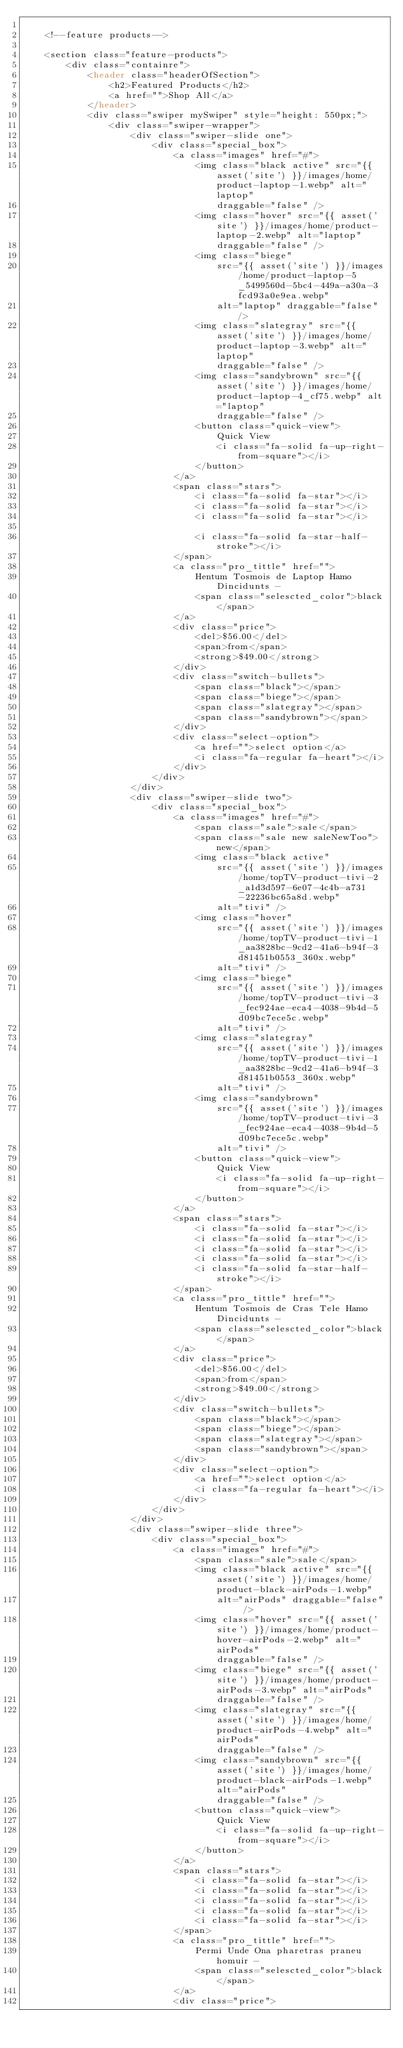Convert code to text. <code><loc_0><loc_0><loc_500><loc_500><_PHP_>
    <!--feature products-->

    <section class="feature-products">
        <div class="containre">
            <header class="headerOfSection">
                <h2>Featured Products</h2>
                <a href="">Shop All</a>
            </header>
            <div class="swiper mySwiper" style="height: 550px;">
                <div class="swiper-wrapper">
                    <div class="swiper-slide one">
                        <div class="special_box">
                            <a class="images" href="#">
                                <img class="black active" src="{{ asset('site') }}/images/home/product-laptop-1.webp" alt="laptop"
                                    draggable="false" />
                                <img class="hover" src="{{ asset('site') }}/images/home/product-laptop-2.webp" alt="laptop"
                                    draggable="false" />
                                <img class="biege"
                                    src="{{ asset('site') }}/images/home/product-laptop-5_5499560d-5bc4-449a-a30a-3fcd93a0e9ea.webp"
                                    alt="laptop" draggable="false" />
                                <img class="slategray" src="{{ asset('site') }}/images/home/product-laptop-3.webp" alt="laptop"
                                    draggable="false" />
                                <img class="sandybrown" src="{{ asset('site') }}/images/home/product-laptop-4_cf75.webp" alt="laptop"
                                    draggable="false" />
                                <button class="quick-view">
                                    Quick View
                                    <i class="fa-solid fa-up-right-from-square"></i>
                                </button>
                            </a>
                            <span class="stars">
                                <i class="fa-solid fa-star"></i>
                                <i class="fa-solid fa-star"></i>
                                <i class="fa-solid fa-star"></i>

                                <i class="fa-solid fa-star-half-stroke"></i>
                            </span>
                            <a class="pro_tittle" href="">
                                Hentum Tosmois de Laptop Hamo Dincidunts -
                                <span class="selescted_color">black</span>
                            </a>
                            <div class="price">
                                <del>$56.00</del>
                                <span>from</span>
                                <strong>$49.00</strong>
                            </div>
                            <div class="switch-bullets">
                                <span class="black"></span>
                                <span class="biege"></span>
                                <span class="slategray"></span>
                                <span class="sandybrown"></span>
                            </div>
                            <div class="select-option">
                                <a href="">select option</a>
                                <i class="fa-regular fa-heart"></i>
                            </div>
                        </div>
                    </div>
                    <div class="swiper-slide two">
                        <div class="special_box">
                            <a class="images" href="#">
                                <span class="sale">sale</span>
                                <span class="sale new saleNewToo">new</span>
                                <img class="black active"
                                    src="{{ asset('site') }}/images/home/topTV-product-tivi-2_a1d3d597-6e07-4c4b-a731-22236bc65a8d.webp"
                                    alt="tivi" />
                                <img class="hover"
                                    src="{{ asset('site') }}/images/home/topTV-product-tivi-1_aa3828bc-9cd2-41a6-b94f-3d81451b0553_360x.webp"
                                    alt="tivi" />
                                <img class="biege"
                                    src="{{ asset('site') }}/images/home/topTV-product-tivi-3_fec924ae-eca4-4038-9b4d-5d09bc7ece5c.webp"
                                    alt="tivi" />
                                <img class="slategray"
                                    src="{{ asset('site') }}/images/home/topTV-product-tivi-1_aa3828bc-9cd2-41a6-b94f-3d81451b0553_360x.webp"
                                    alt="tivi" />
                                <img class="sandybrown"
                                    src="{{ asset('site') }}/images/home/topTV-product-tivi-3_fec924ae-eca4-4038-9b4d-5d09bc7ece5c.webp"
                                    alt="tivi" />
                                <button class="quick-view">
                                    Quick View
                                    <i class="fa-solid fa-up-right-from-square"></i>
                                </button>
                            </a>
                            <span class="stars">
                                <i class="fa-solid fa-star"></i>
                                <i class="fa-solid fa-star"></i>
                                <i class="fa-solid fa-star"></i>
                                <i class="fa-solid fa-star"></i>
                                <i class="fa-solid fa-star-half-stroke"></i>
                            </span>
                            <a class="pro_tittle" href="">
                                Hentum Tosmois de Cras Tele Hamo Dincidunts -
                                <span class="selescted_color">black</span>
                            </a>
                            <div class="price">
                                <del>$56.00</del>
                                <span>from</span>
                                <strong>$49.00</strong>
                            </div>
                            <div class="switch-bullets">
                                <span class="black"></span>
                                <span class="biege"></span>
                                <span class="slategray"></span>
                                <span class="sandybrown"></span>
                            </div>
                            <div class="select-option">
                                <a href="">select option</a>
                                <i class="fa-regular fa-heart"></i>
                            </div>
                        </div>
                    </div>
                    <div class="swiper-slide three">
                        <div class="special_box">
                            <a class="images" href="#">
                                <span class="sale">sale</span>
                                <img class="black active" src="{{ asset('site') }}/images/home/product-black-airPods-1.webp"
                                    alt="airPods" draggable="false" />
                                <img class="hover" src="{{ asset('site') }}/images/home/product-hover-airPods-2.webp" alt="airPods"
                                    draggable="false" />
                                <img class="biege" src="{{ asset('site') }}/images/home/product-airPods-3.webp" alt="airPods"
                                    draggable="false" />
                                <img class="slategray" src="{{ asset('site') }}/images/home/product-airPods-4.webp" alt="airPods"
                                    draggable="false" />
                                <img class="sandybrown" src="{{ asset('site') }}/images/home/product-black-airPods-1.webp" alt="airPods"
                                    draggable="false" />
                                <button class="quick-view">
                                    Quick View
                                    <i class="fa-solid fa-up-right-from-square"></i>
                                </button>
                            </a>
                            <span class="stars">
                                <i class="fa-solid fa-star"></i>
                                <i class="fa-solid fa-star"></i>
                                <i class="fa-solid fa-star"></i>
                                <i class="fa-solid fa-star"></i>
                                <i class="fa-solid fa-star"></i>
                            </span>
                            <a class="pro_tittle" href="">
                                Permi Unde Ona pharetras praneu homuir -
                                <span class="selescted_color">black</span>
                            </a>
                            <div class="price"></code> 